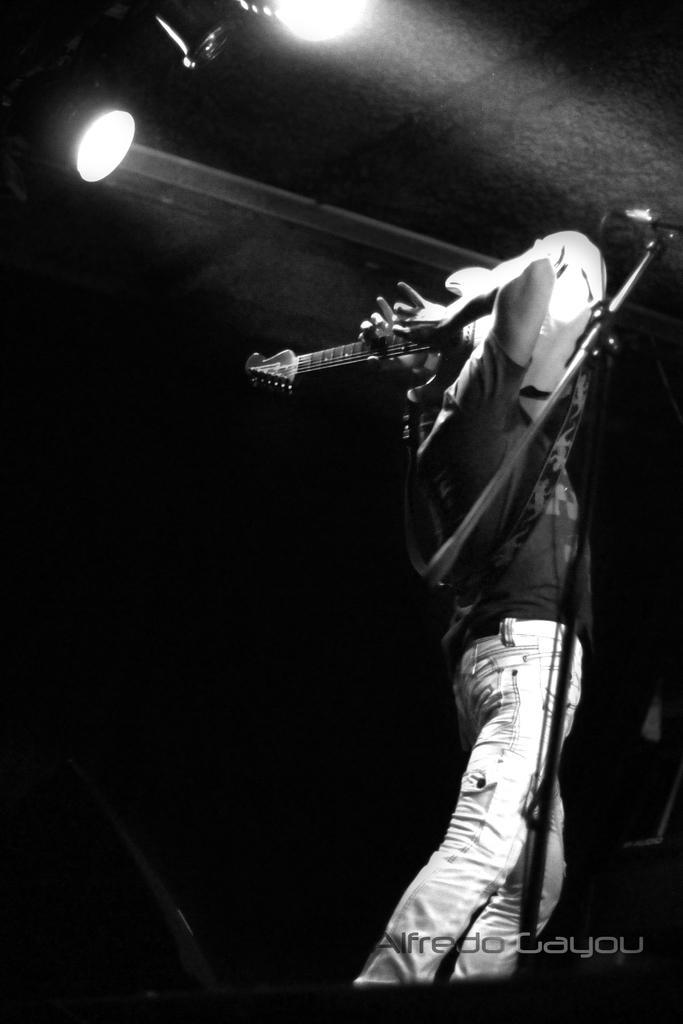In one or two sentences, can you explain what this image depicts? He is standing. His playing a musical instruments. We can see in the background there is a lights. 